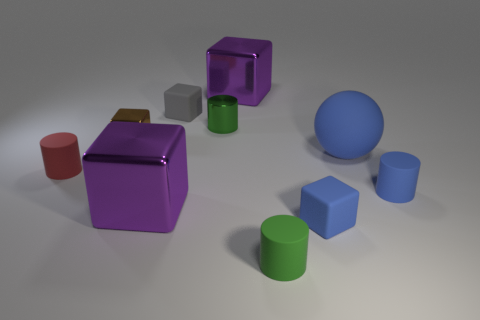The sphere that is in front of the shiny cylinder is what color?
Offer a very short reply. Blue. There is a tiny green object behind the big blue object; is there a cylinder on the left side of it?
Keep it short and to the point. Yes. How many things are either small matte blocks that are behind the rubber ball or tiny yellow cylinders?
Keep it short and to the point. 1. Is there anything else that has the same size as the blue rubber cylinder?
Ensure brevity in your answer.  Yes. There is a big purple block behind the big shiny object that is in front of the blue cylinder; what is it made of?
Provide a succinct answer. Metal. Are there the same number of tiny cylinders that are behind the green metallic cylinder and brown metal cubes that are right of the brown block?
Provide a succinct answer. Yes. How many things are either tiny matte blocks that are behind the large matte object or cylinders that are on the left side of the big blue thing?
Keep it short and to the point. 4. What is the tiny cube that is both in front of the small gray matte block and to the left of the tiny green matte object made of?
Ensure brevity in your answer.  Metal. There is a green object in front of the tiny rubber cylinder on the left side of the big purple thing that is in front of the small red matte thing; how big is it?
Your answer should be very brief. Small. Are there more blue things than large brown matte balls?
Give a very brief answer. Yes. 